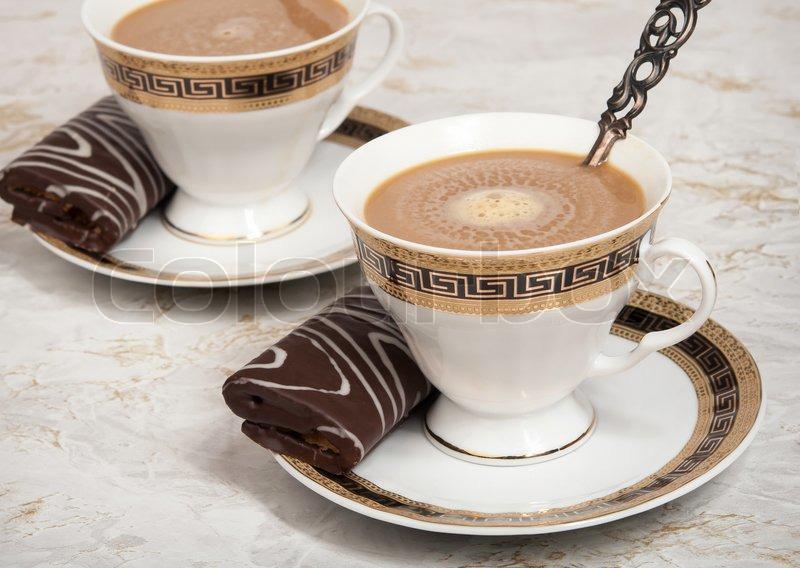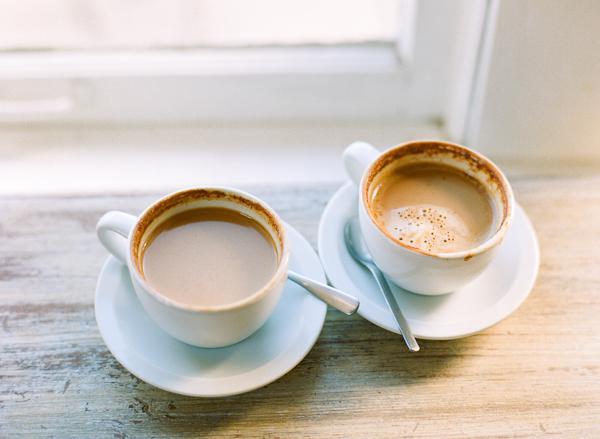The first image is the image on the left, the second image is the image on the right. Considering the images on both sides, is "The left image features two spoons and two beverages in cups." valid? Answer yes or no. No. The first image is the image on the left, the second image is the image on the right. Examine the images to the left and right. Is the description "Two spoons are visible in the left image." accurate? Answer yes or no. No. 